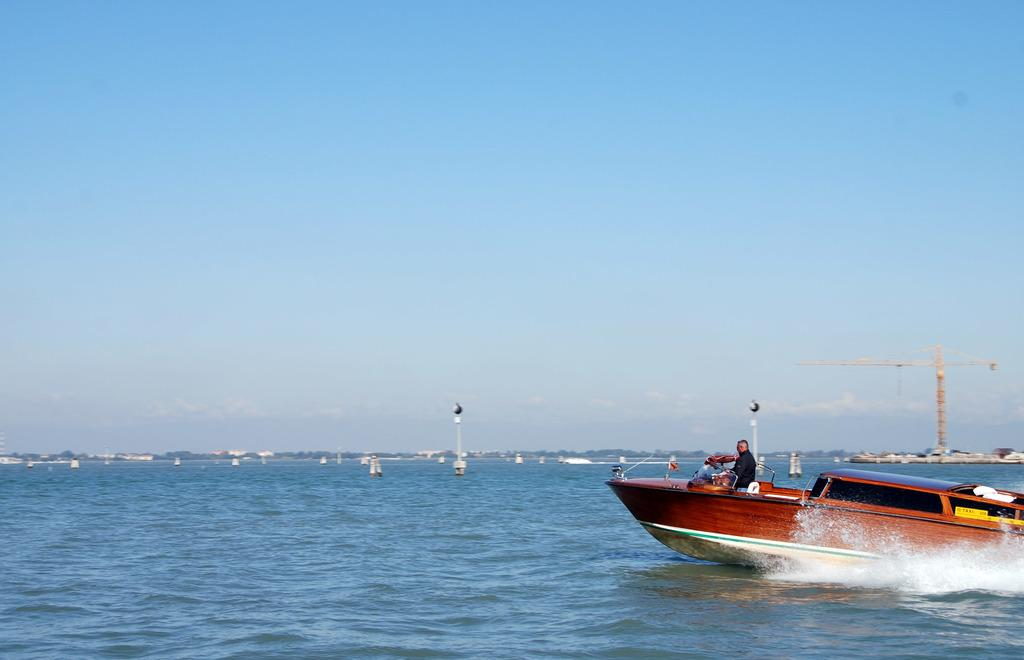What is on the water in the image? There are boats on the water in the image. What else can be seen in the image besides the boats? There are poles and a crane in the image. What is visible in the background of the image? The sky is visible in the background of the image. What type of root can be seen growing near the boats in the image? There is no root visible in the image; it features boats on the water, poles, a crane, and the sky. What substance is being poured from the crane in the image? There is no substance being poured from the crane in the image; it is a stationary object. 